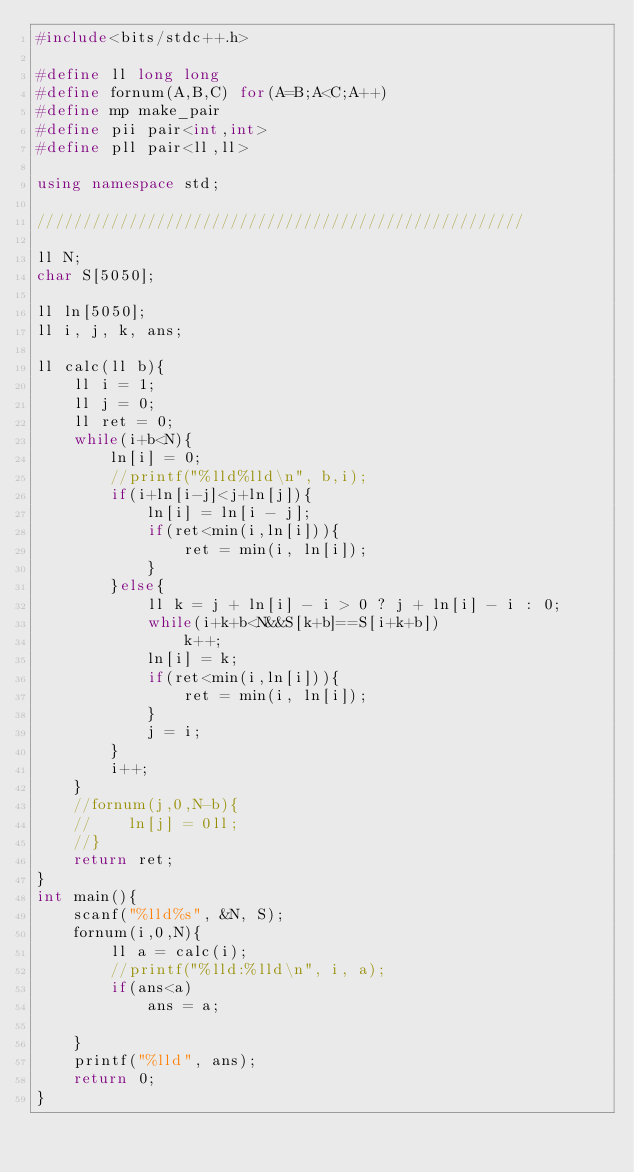<code> <loc_0><loc_0><loc_500><loc_500><_C++_>#include<bits/stdc++.h>

#define ll long long
#define fornum(A,B,C) for(A=B;A<C;A++)
#define mp make_pair
#define pii pair<int,int>
#define pll pair<ll,ll>

using namespace std;

/////////////////////////////////////////////////////

ll N;
char S[5050];

ll ln[5050];
ll i, j, k, ans;

ll calc(ll b){
    ll i = 1;
    ll j = 0;
    ll ret = 0;
    while(i+b<N){
        ln[i] = 0;
        //printf("%lld%lld\n", b,i);
        if(i+ln[i-j]<j+ln[j]){
            ln[i] = ln[i - j];
            if(ret<min(i,ln[i])){
                ret = min(i, ln[i]);
            }
        }else{
            ll k = j + ln[i] - i > 0 ? j + ln[i] - i : 0;
            while(i+k+b<N&&S[k+b]==S[i+k+b])
                k++;
            ln[i] = k;
            if(ret<min(i,ln[i])){
                ret = min(i, ln[i]);
            }
            j = i;
        }
        i++;
    }
    //fornum(j,0,N-b){
    //    ln[j] = 0ll;
    //}
    return ret;
}
int main(){
    scanf("%lld%s", &N, S);
    fornum(i,0,N){
        ll a = calc(i);
        //printf("%lld:%lld\n", i, a);
        if(ans<a)
            ans = a;
        
    }
    printf("%lld", ans);
    return 0;
}
</code> 